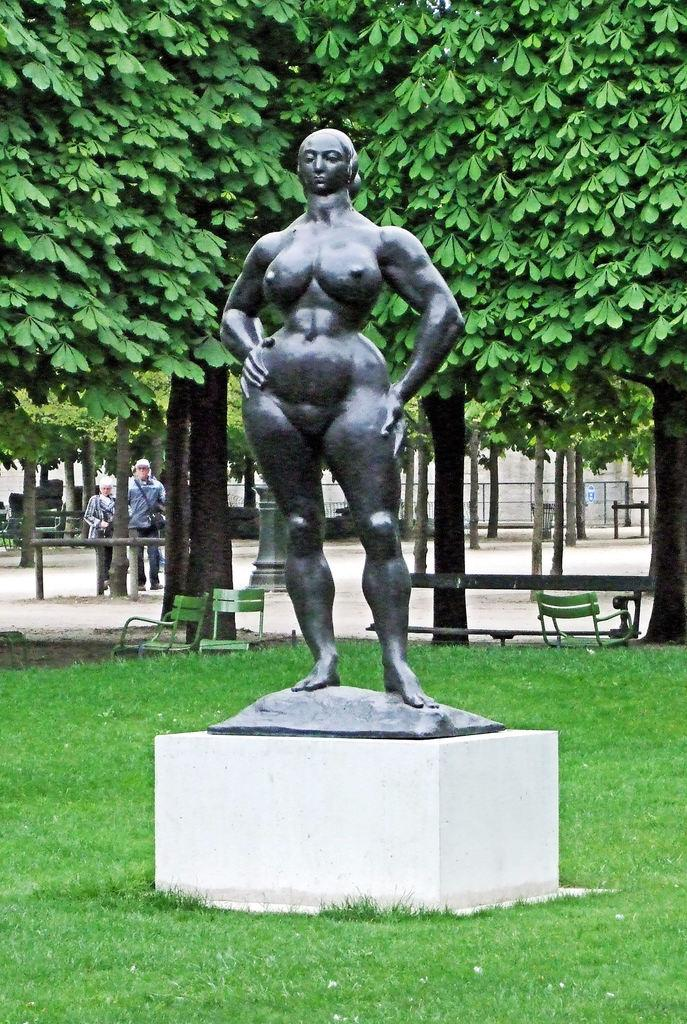What is the main subject in the center of the image? There is a statue in the center of the image. What can be seen in the background of the image? There are trees, two persons, and benches in the background of the image. What is visible on the ground in the image? The ground is visible in the image, and grass is present at the bottom of the image. Where is the rake being used in the image? There is no rake present in the image. What type of nest can be seen in the image? There is no nest present in the image. 